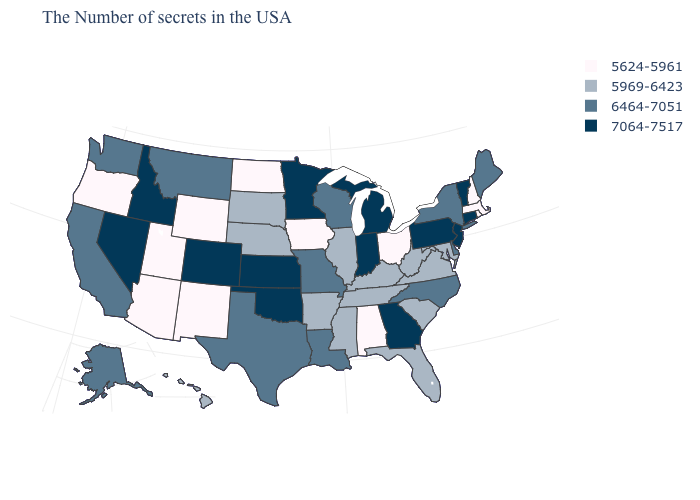Name the states that have a value in the range 7064-7517?
Keep it brief. Vermont, Connecticut, New Jersey, Pennsylvania, Georgia, Michigan, Indiana, Minnesota, Kansas, Oklahoma, Colorado, Idaho, Nevada. What is the value of Pennsylvania?
Write a very short answer. 7064-7517. Does the map have missing data?
Short answer required. No. Does the first symbol in the legend represent the smallest category?
Be succinct. Yes. What is the value of Arkansas?
Quick response, please. 5969-6423. Among the states that border Arizona , which have the lowest value?
Short answer required. New Mexico, Utah. Among the states that border Utah , does Nevada have the highest value?
Give a very brief answer. Yes. Does Alabama have the lowest value in the USA?
Short answer required. Yes. Among the states that border Rhode Island , which have the highest value?
Keep it brief. Connecticut. Does Indiana have the lowest value in the MidWest?
Keep it brief. No. Does Illinois have the highest value in the MidWest?
Write a very short answer. No. Which states have the lowest value in the USA?
Quick response, please. Massachusetts, Rhode Island, New Hampshire, Ohio, Alabama, Iowa, North Dakota, Wyoming, New Mexico, Utah, Arizona, Oregon. Name the states that have a value in the range 6464-7051?
Give a very brief answer. Maine, New York, Delaware, North Carolina, Wisconsin, Louisiana, Missouri, Texas, Montana, California, Washington, Alaska. What is the value of Oklahoma?
Short answer required. 7064-7517. What is the value of California?
Short answer required. 6464-7051. 